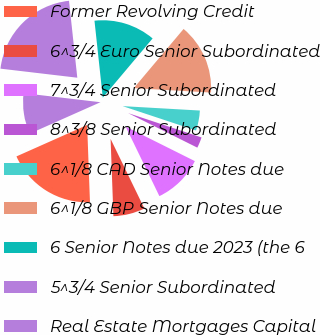Convert chart to OTSL. <chart><loc_0><loc_0><loc_500><loc_500><pie_chart><fcel>Former Revolving Credit<fcel>6^3/4 Euro Senior Subordinated<fcel>7^3/4 Senior Subordinated<fcel>8^3/8 Senior Subordinated<fcel>6^1/8 CAD Senior Notes due<fcel>6^1/8 GBP Senior Notes due<fcel>6 Senior Notes due 2023 (the 6<fcel>5^3/4 Senior Subordinated<fcel>Real Estate Mortgages Capital<nl><fcel>18.92%<fcel>6.61%<fcel>10.44%<fcel>2.27%<fcel>4.19%<fcel>14.77%<fcel>12.85%<fcel>21.42%<fcel>8.53%<nl></chart> 